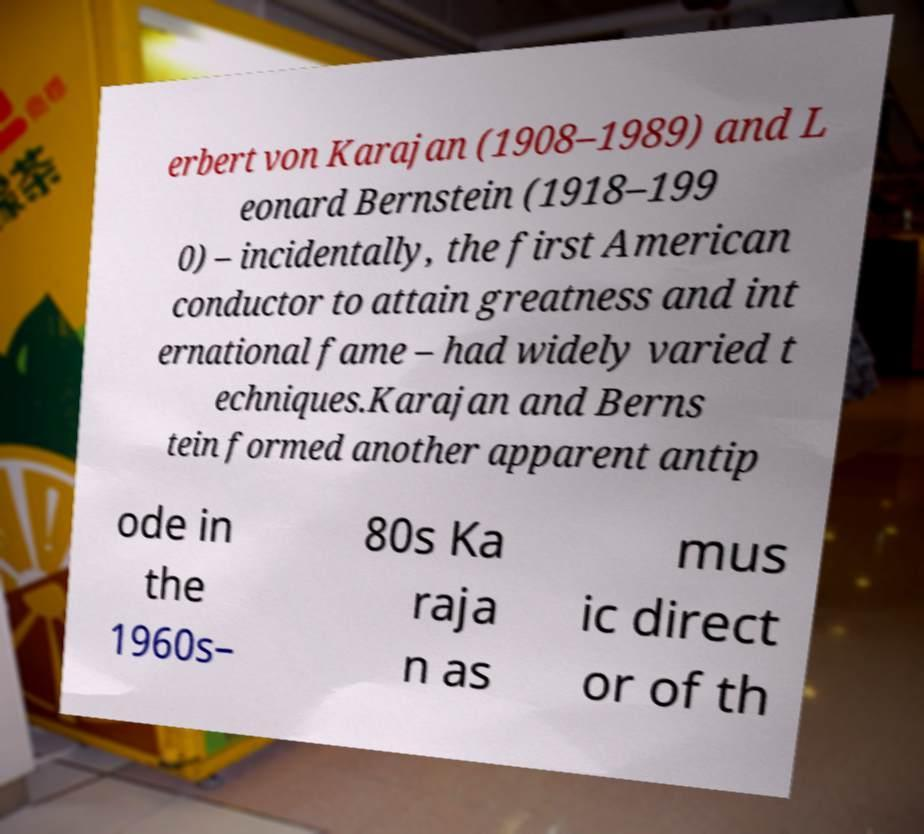For documentation purposes, I need the text within this image transcribed. Could you provide that? erbert von Karajan (1908–1989) and L eonard Bernstein (1918–199 0) – incidentally, the first American conductor to attain greatness and int ernational fame – had widely varied t echniques.Karajan and Berns tein formed another apparent antip ode in the 1960s– 80s Ka raja n as mus ic direct or of th 